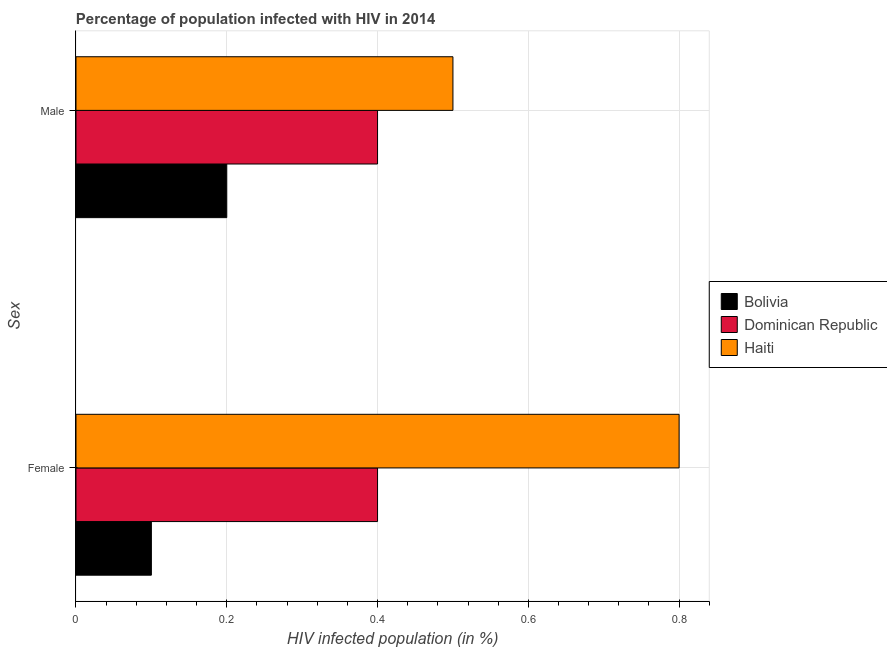How many groups of bars are there?
Give a very brief answer. 2. Are the number of bars on each tick of the Y-axis equal?
Provide a short and direct response. Yes. How many bars are there on the 1st tick from the top?
Ensure brevity in your answer.  3. What is the label of the 2nd group of bars from the top?
Your answer should be compact. Female. In which country was the percentage of females who are infected with hiv maximum?
Your answer should be very brief. Haiti. What is the total percentage of females who are infected with hiv in the graph?
Your response must be concise. 1.3. What is the difference between the percentage of females who are infected with hiv in Haiti and the percentage of males who are infected with hiv in Bolivia?
Your answer should be very brief. 0.6. What is the average percentage of females who are infected with hiv per country?
Offer a very short reply. 0.43. In how many countries, is the percentage of females who are infected with hiv greater than 0.2 %?
Offer a terse response. 2. What is the ratio of the percentage of females who are infected with hiv in Dominican Republic to that in Haiti?
Your response must be concise. 0.5. What does the 1st bar from the bottom in Female represents?
Keep it short and to the point. Bolivia. How many bars are there?
Make the answer very short. 6. Are all the bars in the graph horizontal?
Provide a succinct answer. Yes. What is the difference between two consecutive major ticks on the X-axis?
Provide a succinct answer. 0.2. Does the graph contain any zero values?
Provide a succinct answer. No. Does the graph contain grids?
Your answer should be very brief. Yes. What is the title of the graph?
Offer a very short reply. Percentage of population infected with HIV in 2014. What is the label or title of the X-axis?
Your answer should be very brief. HIV infected population (in %). What is the label or title of the Y-axis?
Offer a very short reply. Sex. What is the HIV infected population (in %) of Bolivia in Female?
Offer a terse response. 0.1. What is the HIV infected population (in %) in Dominican Republic in Female?
Give a very brief answer. 0.4. What is the HIV infected population (in %) in Haiti in Female?
Offer a very short reply. 0.8. What is the HIV infected population (in %) in Bolivia in Male?
Ensure brevity in your answer.  0.2. What is the HIV infected population (in %) in Dominican Republic in Male?
Your response must be concise. 0.4. What is the HIV infected population (in %) in Haiti in Male?
Your answer should be compact. 0.5. Across all Sex, what is the maximum HIV infected population (in %) of Bolivia?
Give a very brief answer. 0.2. Across all Sex, what is the maximum HIV infected population (in %) in Dominican Republic?
Your response must be concise. 0.4. Across all Sex, what is the maximum HIV infected population (in %) of Haiti?
Offer a terse response. 0.8. Across all Sex, what is the minimum HIV infected population (in %) in Bolivia?
Offer a very short reply. 0.1. What is the total HIV infected population (in %) of Dominican Republic in the graph?
Your answer should be very brief. 0.8. What is the total HIV infected population (in %) in Haiti in the graph?
Provide a succinct answer. 1.3. What is the difference between the HIV infected population (in %) of Bolivia in Female and that in Male?
Provide a succinct answer. -0.1. What is the difference between the HIV infected population (in %) in Bolivia in Female and the HIV infected population (in %) in Dominican Republic in Male?
Make the answer very short. -0.3. What is the difference between the HIV infected population (in %) of Bolivia in Female and the HIV infected population (in %) of Haiti in Male?
Your answer should be very brief. -0.4. What is the difference between the HIV infected population (in %) of Dominican Republic in Female and the HIV infected population (in %) of Haiti in Male?
Offer a terse response. -0.1. What is the average HIV infected population (in %) in Haiti per Sex?
Your response must be concise. 0.65. What is the difference between the HIV infected population (in %) of Bolivia and HIV infected population (in %) of Dominican Republic in Female?
Your response must be concise. -0.3. What is the difference between the HIV infected population (in %) in Bolivia and HIV infected population (in %) in Haiti in Female?
Make the answer very short. -0.7. What is the difference between the HIV infected population (in %) in Bolivia and HIV infected population (in %) in Dominican Republic in Male?
Give a very brief answer. -0.2. What is the ratio of the HIV infected population (in %) in Dominican Republic in Female to that in Male?
Provide a succinct answer. 1. What is the ratio of the HIV infected population (in %) of Haiti in Female to that in Male?
Keep it short and to the point. 1.6. What is the difference between the highest and the second highest HIV infected population (in %) in Bolivia?
Provide a short and direct response. 0.1. What is the difference between the highest and the lowest HIV infected population (in %) in Bolivia?
Your response must be concise. 0.1. 